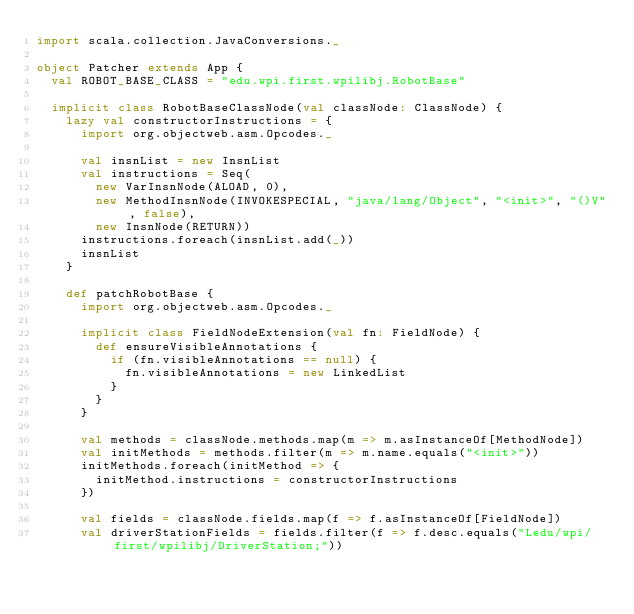<code> <loc_0><loc_0><loc_500><loc_500><_Scala_>import scala.collection.JavaConversions._

object Patcher extends App {
  val ROBOT_BASE_CLASS = "edu.wpi.first.wpilibj.RobotBase"

  implicit class RobotBaseClassNode(val classNode: ClassNode) {
    lazy val constructorInstructions = {
      import org.objectweb.asm.Opcodes._

      val insnList = new InsnList
      val instructions = Seq(
        new VarInsnNode(ALOAD, 0),
        new MethodInsnNode(INVOKESPECIAL, "java/lang/Object", "<init>", "()V", false),
        new InsnNode(RETURN))
      instructions.foreach(insnList.add(_))
      insnList
    }

    def patchRobotBase {
      import org.objectweb.asm.Opcodes._

      implicit class FieldNodeExtension(val fn: FieldNode) {
        def ensureVisibleAnnotations {
          if (fn.visibleAnnotations == null) {
            fn.visibleAnnotations = new LinkedList
          }
        }
      }

      val methods = classNode.methods.map(m => m.asInstanceOf[MethodNode])
      val initMethods = methods.filter(m => m.name.equals("<init>"))
      initMethods.foreach(initMethod => {
        initMethod.instructions = constructorInstructions
      })

      val fields = classNode.fields.map(f => f.asInstanceOf[FieldNode])
      val driverStationFields = fields.filter(f => f.desc.equals("Ledu/wpi/first/wpilibj/DriverStation;"))</code> 